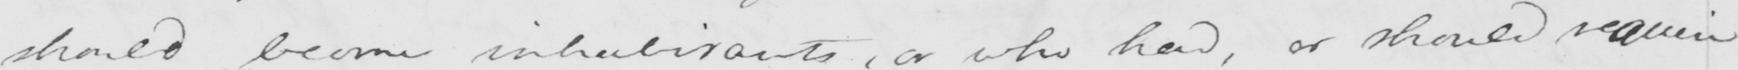What is written in this line of handwriting? should become inhabitants , or who had , or should regain 